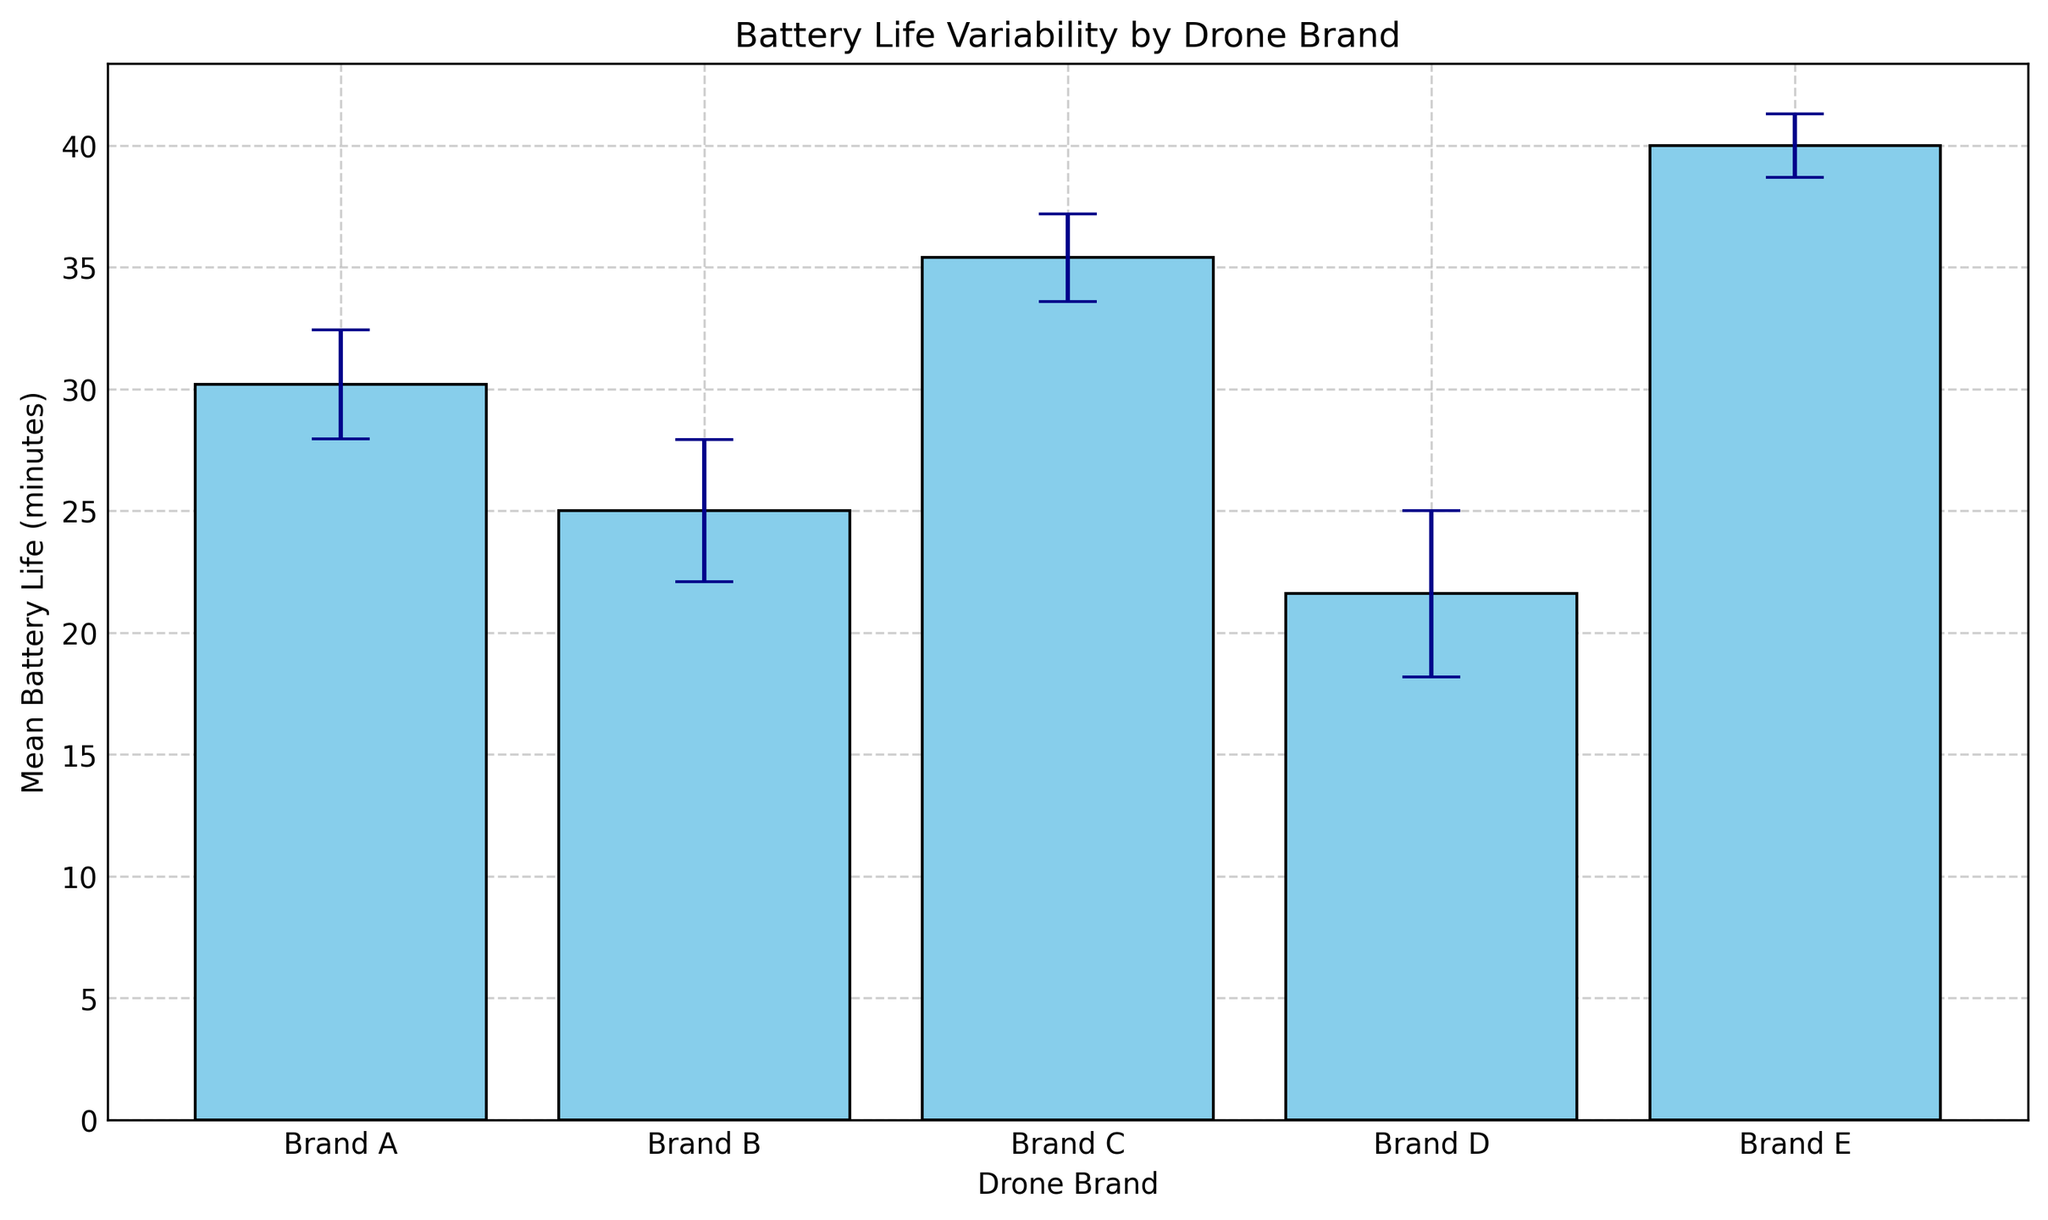Which brand has the highest mean battery life based on the chart? By observing the height of the bars on the chart, we can see that Brand E has the tallest bar, indicating the highest mean battery life.
Answer: Brand E Which brand has the lowest mean battery life based on the chart? By examining the height of the bars on the chart, we notice that Brand D has the shortest bar, indicating the lowest mean battery life.
Answer: Brand D Comparing Brand A and Brand B, which one has a higher mean battery life? Looking at the bars for Brand A and Brand B, Brand A's bar is taller than Brand B's bar, indicating a higher mean battery life.
Answer: Brand A Which brands have their mean battery life exceeding 30 minutes? By observing the heights of the bars and checking their labels, we see that Brand C and Brand E have bars exceeding the 30-minute mark.
Answer: Brand C, Brand E What's the difference in mean battery life between Brand C and Brand D? Measure the height difference between the bars representing Brand C and Brand D. Brand C's mean battery life (~35.4 minutes) minus Brand D's mean battery life (~21.6 minutes) gives the difference.
Answer: ~13.8 minutes How does the variability (standard deviation) compare between Brand E and Brand B? By looking at the size of the error bars, we notice that Brand B has larger error bars, indicating more variability compared to Brand E, which has smaller error bars.
Answer: Brand B has more variability How many brands have a mean battery life of approximately 35 minutes or more? By checking the bars on the chart, we find that Brand C and Brand E have mean battery lives of approximately 35 minutes or more.
Answer: 2 brands Which brand has the smallest variability in mean battery life? By examining the size of the error bars, Brand E has the smallest error bars, indicating the smallest variability.
Answer: Brand E For Brand B, what is the mean battery life, and what is the approximate range within one standard deviation? The mean battery life for Brand B is around 25 minutes. The standard deviation is approximately 2.92 minutes. So, the range is roughly 25 ± 2.92 minutes, which is about 22.08 to 27.92 minutes.
Answer: ~22.08 to ~27.92 minutes Which brand shows the most consistency in their battery life based on the error bars? By comparing the error bars, Brand E has the smallest error bars, indicating the most consistency in battery life.
Answer: Brand E 